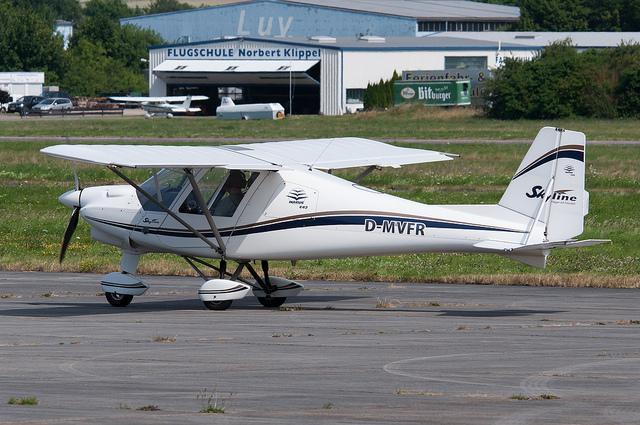How many people are with the plane?
Give a very brief answer. 1. 